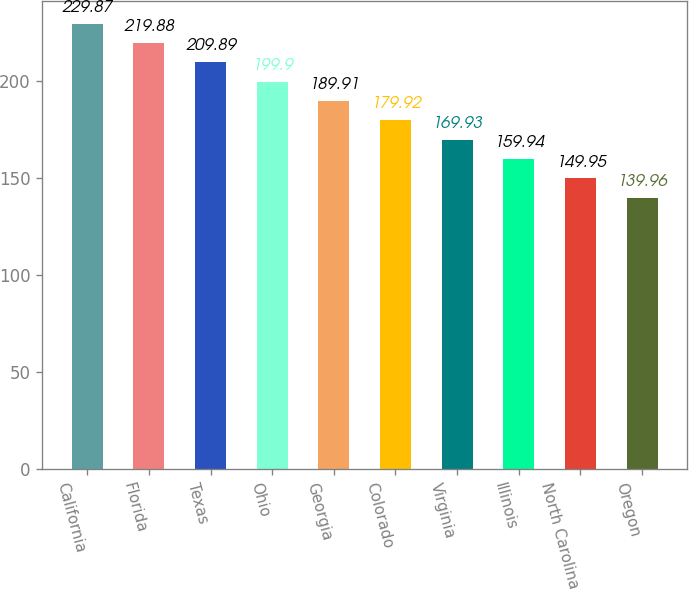Convert chart. <chart><loc_0><loc_0><loc_500><loc_500><bar_chart><fcel>California<fcel>Florida<fcel>Texas<fcel>Ohio<fcel>Georgia<fcel>Colorado<fcel>Virginia<fcel>Illinois<fcel>North Carolina<fcel>Oregon<nl><fcel>229.87<fcel>219.88<fcel>209.89<fcel>199.9<fcel>189.91<fcel>179.92<fcel>169.93<fcel>159.94<fcel>149.95<fcel>139.96<nl></chart> 